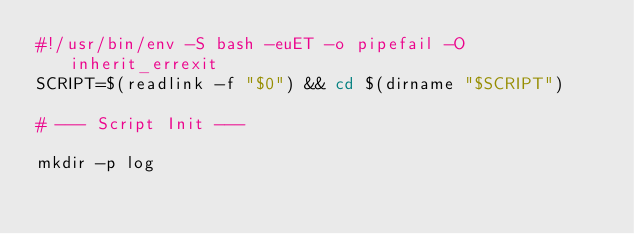Convert code to text. <code><loc_0><loc_0><loc_500><loc_500><_Bash_>#!/usr/bin/env -S bash -euET -o pipefail -O inherit_errexit
SCRIPT=$(readlink -f "$0") && cd $(dirname "$SCRIPT")

# --- Script Init ---

mkdir -p log</code> 